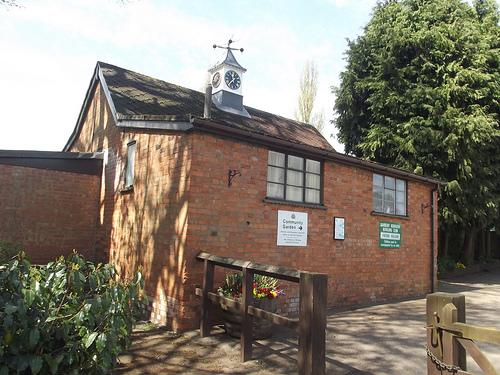Briefly describe an object on the rooftop of the brick building. A weather vane can be seen on the rooftop of the brick building. Provide a concise description of the most prominent structure in the picture. A large brick building with a clock tower stands out as the main structure. Give a brief description of the brick wall in the image. The brick wall is red and features a green poster and a wooden bench in front of it. Just list two items that are located on the roof of the house. A weather vane and a clock are located on the roof of the house. Describe the main scenery shown in the image. The image depicts a brick building with a clock tower surrounded by trees and a wooden fence. Narrate the image scene in a simple sentence. A brick building with a clock tower is surrounded by trees and a wooden fence. What can be found beside the main brick building? A thick, densely planted group of trees can be seen beside the main building. Mention an object that is placed on the wall of the building. A green poster can be seen on the brick wall of the building. Short description of the ground in the image. The ground in front of the building is covered with gravel. Enumerate three objects you can find in the image. A wooden bench, a green poster on the wall, and a weather vane on the roof are present in the image. 